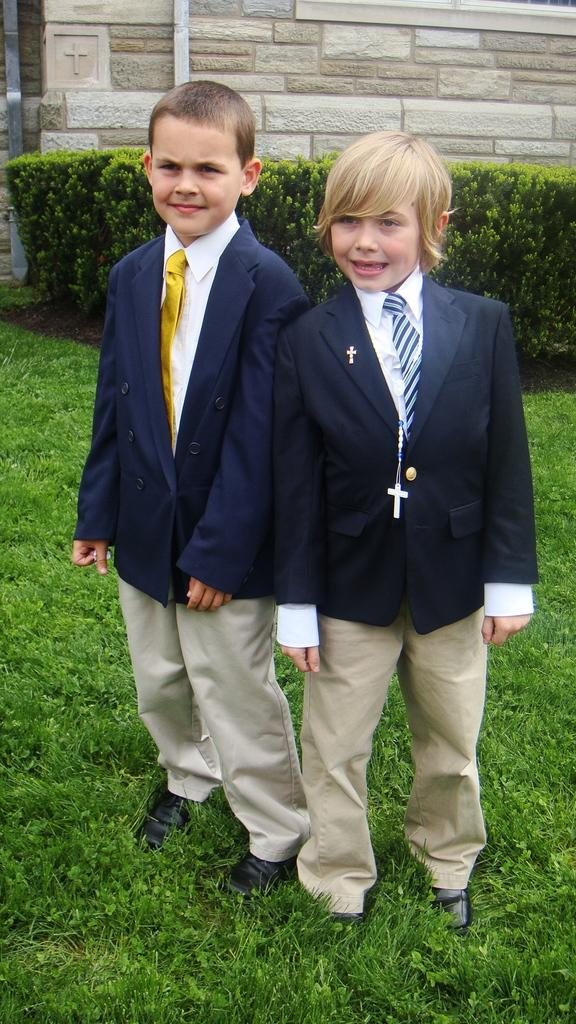What is the main subject of the image? The main subject of the image is the kids standing in the center. What expression do the kids have? The kids are smiling in the image. What can be seen in the background of the image? There are plants and a wall in the background of the image. What type of business is being conducted by the kids in the image? There is no indication of any business being conducted in the image; the kids are simply standing and smiling. Can you tell me how many carriages are visible in the image? There are no carriages present in the image. 